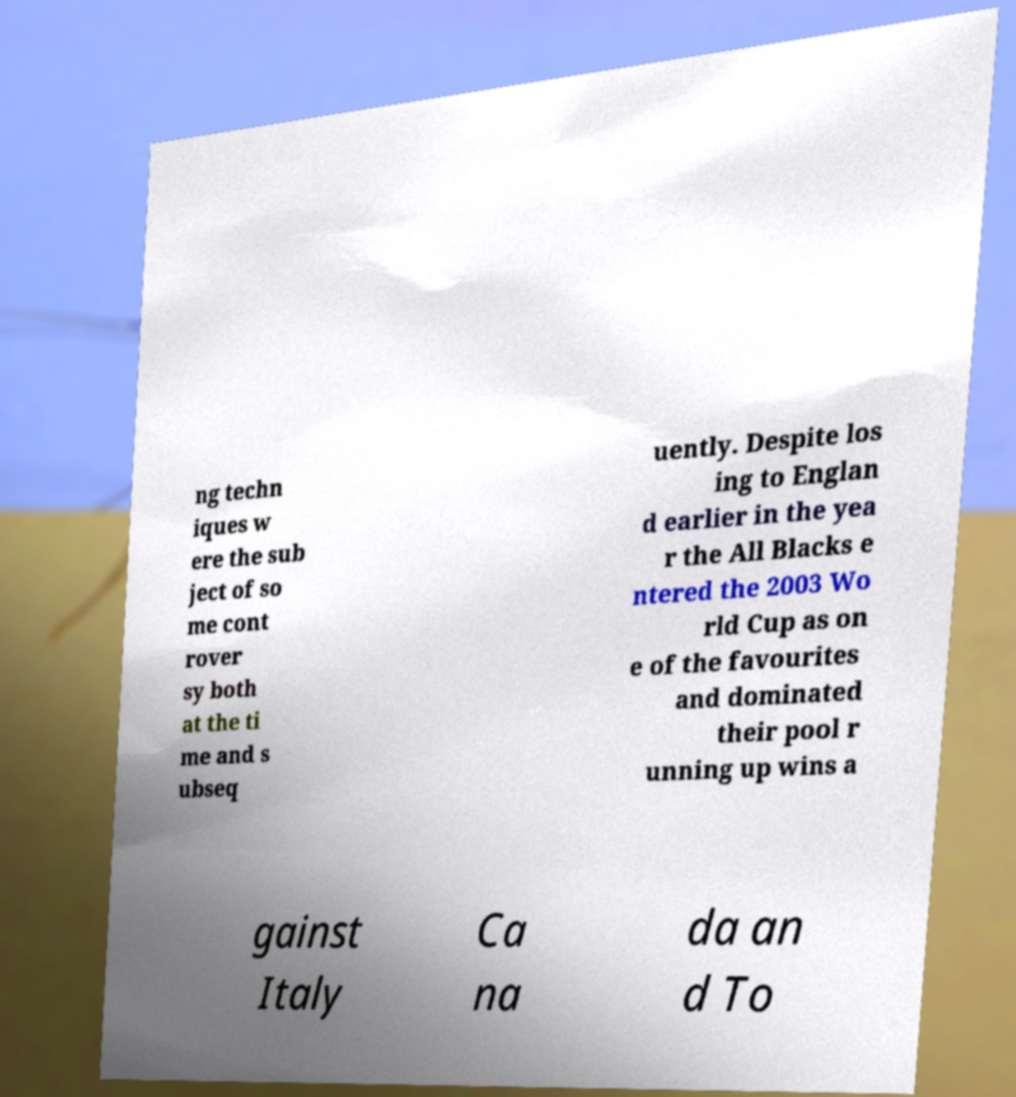Please read and relay the text visible in this image. What does it say? ng techn iques w ere the sub ject of so me cont rover sy both at the ti me and s ubseq uently. Despite los ing to Englan d earlier in the yea r the All Blacks e ntered the 2003 Wo rld Cup as on e of the favourites and dominated their pool r unning up wins a gainst Italy Ca na da an d To 